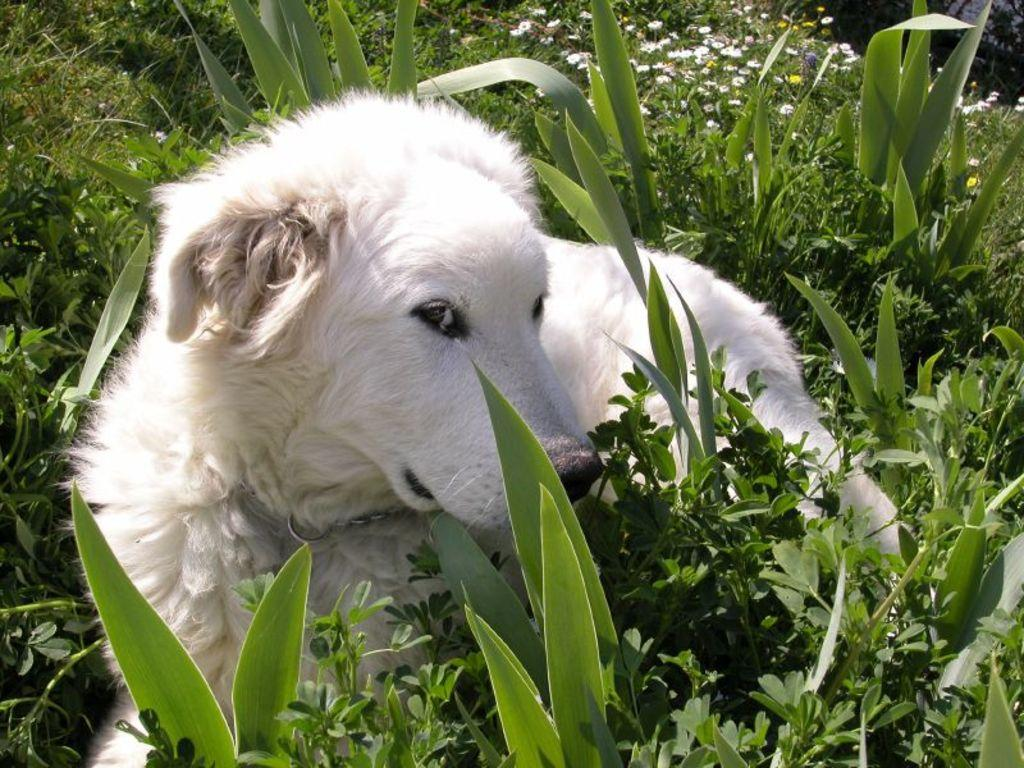What type of animal is in the image? There is a white color dog in the image. What is the dog doing in the image? The dog is laying down. What can be seen at the bottom of the image? There are plants at the bottom of the image. What is visible in the background of the image? Flowers are visible in the background of the image. Where is the patch of crops located in the image? There is no patch of crops present in the image; it features a white color dog laying down with plants at the bottom and flowers in the background. 